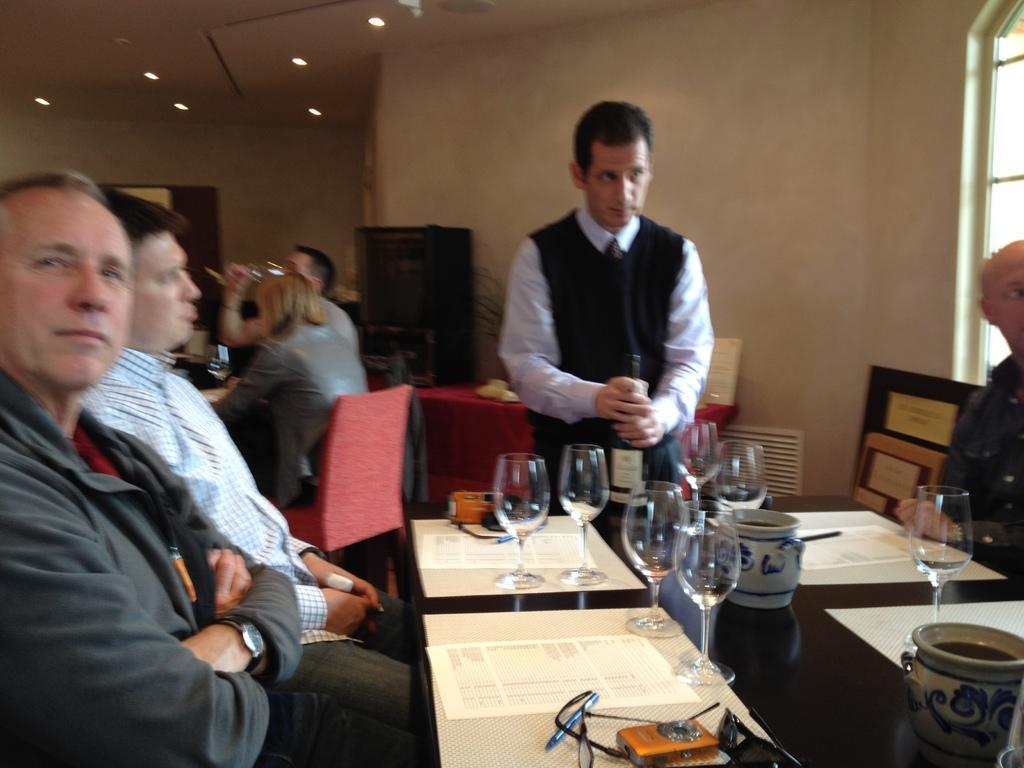Could you give a brief overview of what you see in this image? In this image I see 3 men were sitting on chairs and this man is standing and there is a table in front of them on which there are glasses, cups and other things. In the background I see the wall, few people and the lights on the ceiling. 